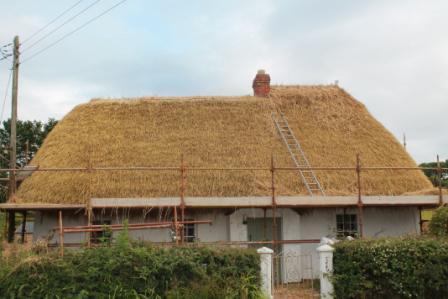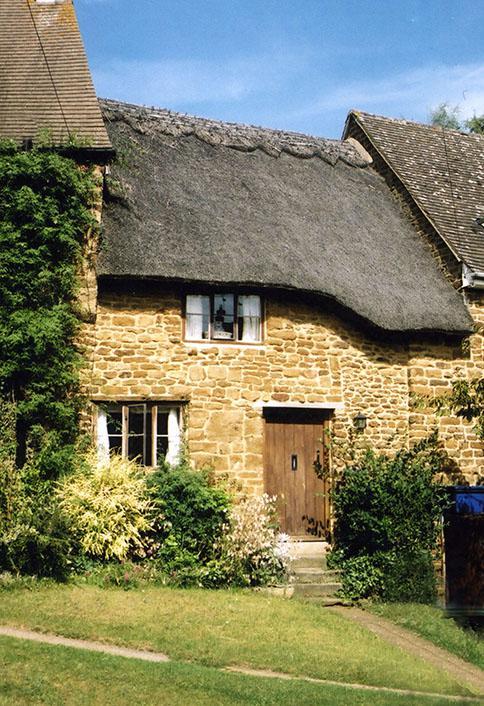The first image is the image on the left, the second image is the image on the right. Assess this claim about the two images: "The right image shows the front of a pale stucco-look house with a scalloped border on the peak of the roof and with two notches in the roof's bottom edge to accommodate windows.". Correct or not? Answer yes or no. No. The first image is the image on the left, the second image is the image on the right. Evaluate the accuracy of this statement regarding the images: "The thatching on the house in the image to the right, is a dark gray.". Is it true? Answer yes or no. Yes. 